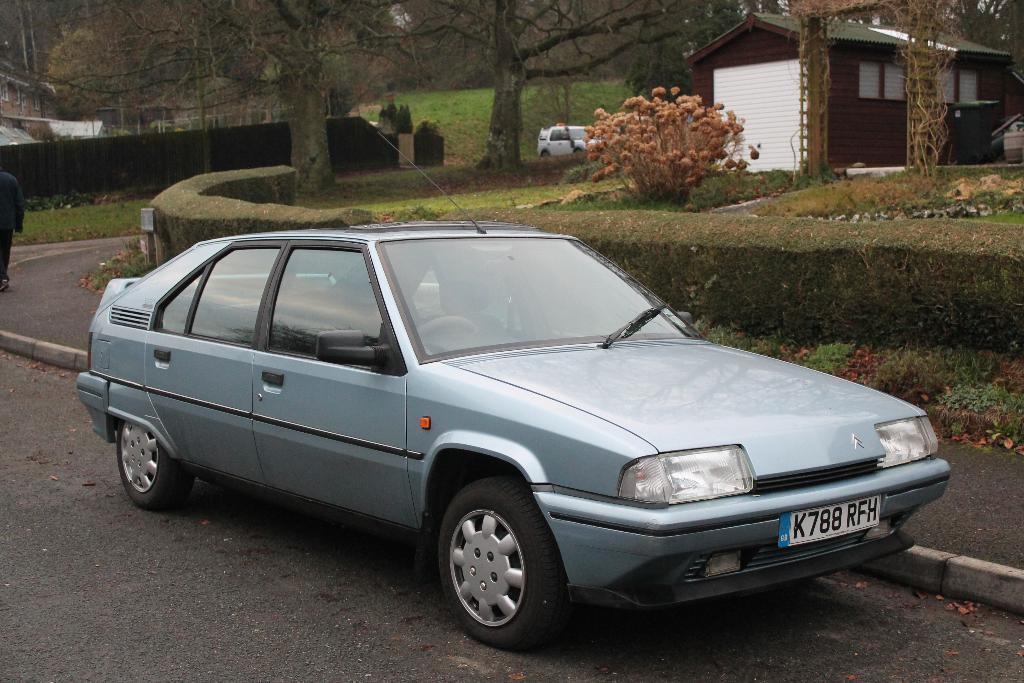How would you summarize this image in a sentence or two? In this image I can see few vehicles. Back Side I can see a house which is in white and brown color. I can see trees and fencing. 